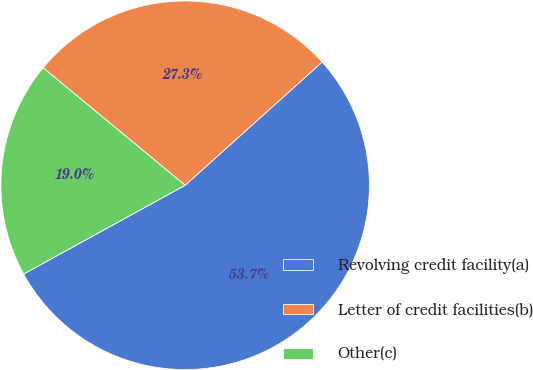<chart> <loc_0><loc_0><loc_500><loc_500><pie_chart><fcel>Revolving credit facility(a)<fcel>Letter of credit facilities(b)<fcel>Other(c)<nl><fcel>53.66%<fcel>27.34%<fcel>19.0%<nl></chart> 